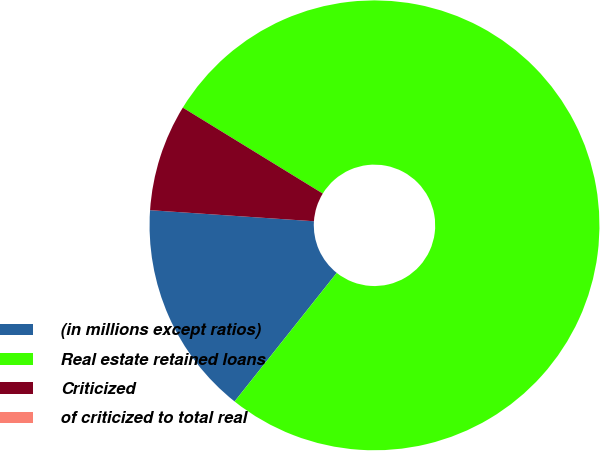Convert chart to OTSL. <chart><loc_0><loc_0><loc_500><loc_500><pie_chart><fcel>(in millions except ratios)<fcel>Real estate retained loans<fcel>Criticized<fcel>of criticized to total real<nl><fcel>15.39%<fcel>76.92%<fcel>7.69%<fcel>0.0%<nl></chart> 